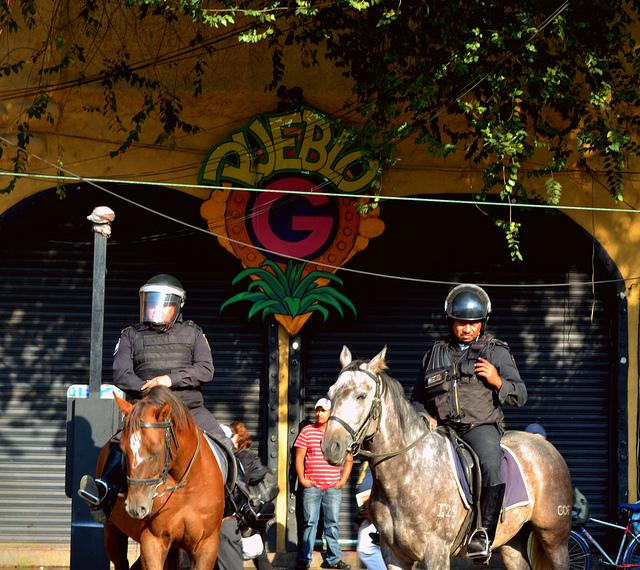What is the profession of the men on horses?

Choices:
A) waiter
B) officer
C) priest
D) doctor officer 